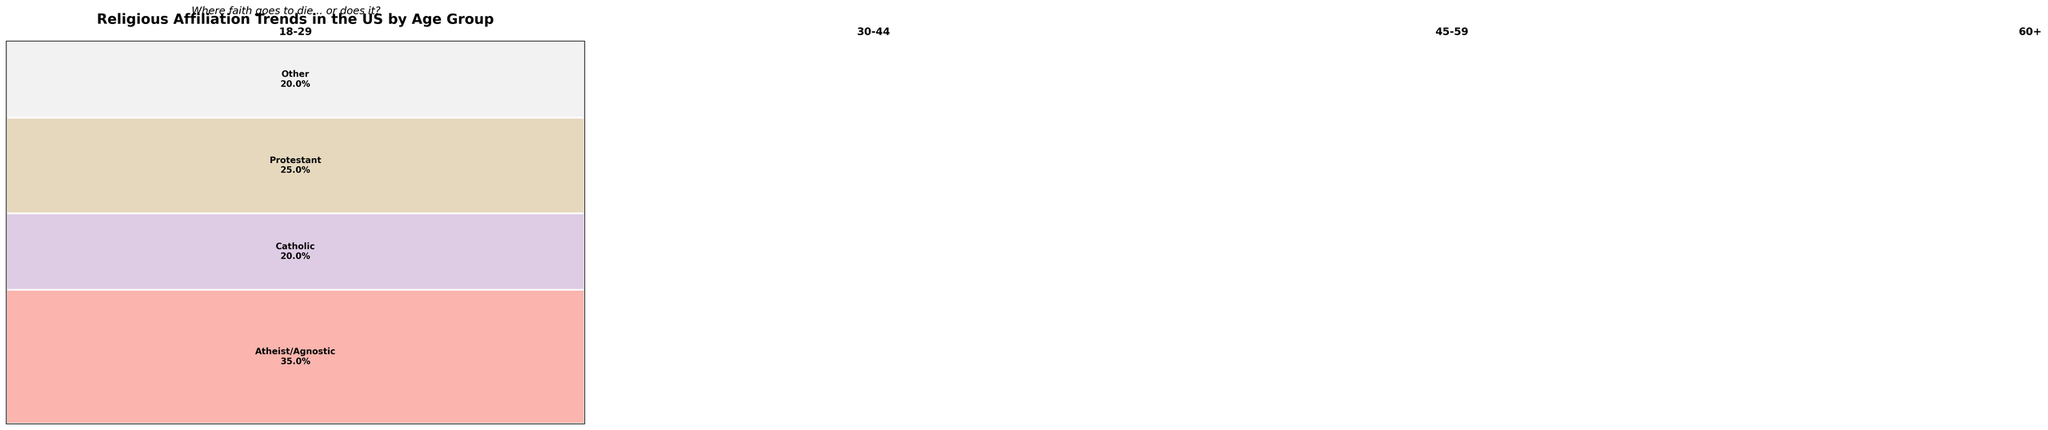Which age group has the highest percentage of Protestants? The tallest section of the mosaic plot for Protestants is in the 60+ age group. This section reaches up to 40%, which is higher than any other age group.
Answer: 60+ How does the percentage of Atheist/Agnostic individuals in the 18-29 age group compare to those in the 60+ age group? The percentage of Atheist/Agnostic individuals in the 18-29 age group is 35%, while in the 60+ age group it is 15%. The 18-29 age group has a higher percentage.
Answer: 18-29 is higher What is the combined percentage of Protestants and Catholics in the 45-59 age group? In the 45-59 age group, Protestants make up 35% and Catholics make up 25%. Combined, this totals 60%.
Answer: 60% Which denomination has the smallest percentage in the 30-44 age group? For the 30-44 age group, Other denominations and Atheist/Agnostic each account for 20%, making them the smallest group at 20%.
Answer: Other and Atheist/Agnostic How does the distribution of denominations in the 45-59 age group compare to the 60+ age group? In the 45-59 age group: Atheist/Agnostic (20%), Catholic (25%), Protestant (35%), Other (20%). In the 60+ age group: Atheist/Agnostic (15%), Catholic (28%), Protestant (40%), Other (17%). The 60+ age group has a higher percentage of Catholics and Protestants, but a lower percentage of Atheist/Agnostic and Other.
Answer: 45-59 has fewer Catholics and Protestants, more Atheist/Agnostic and Other What percentage of the 18-29 age group identify as other denominations? The mosaic plot shows that 20% of the 18-29 age group fall into the 'Other' denomination category.
Answer: 20% Is the percentage of Catholics higher in the 30-44 age group or the 60+ age group? The percentage of Catholics in the 30-44 age group is 22%, whereas in the 60+ age group it is 28%. Thus, the 60+ age group has a higher percentage of Catholics.
Answer: 60+ 